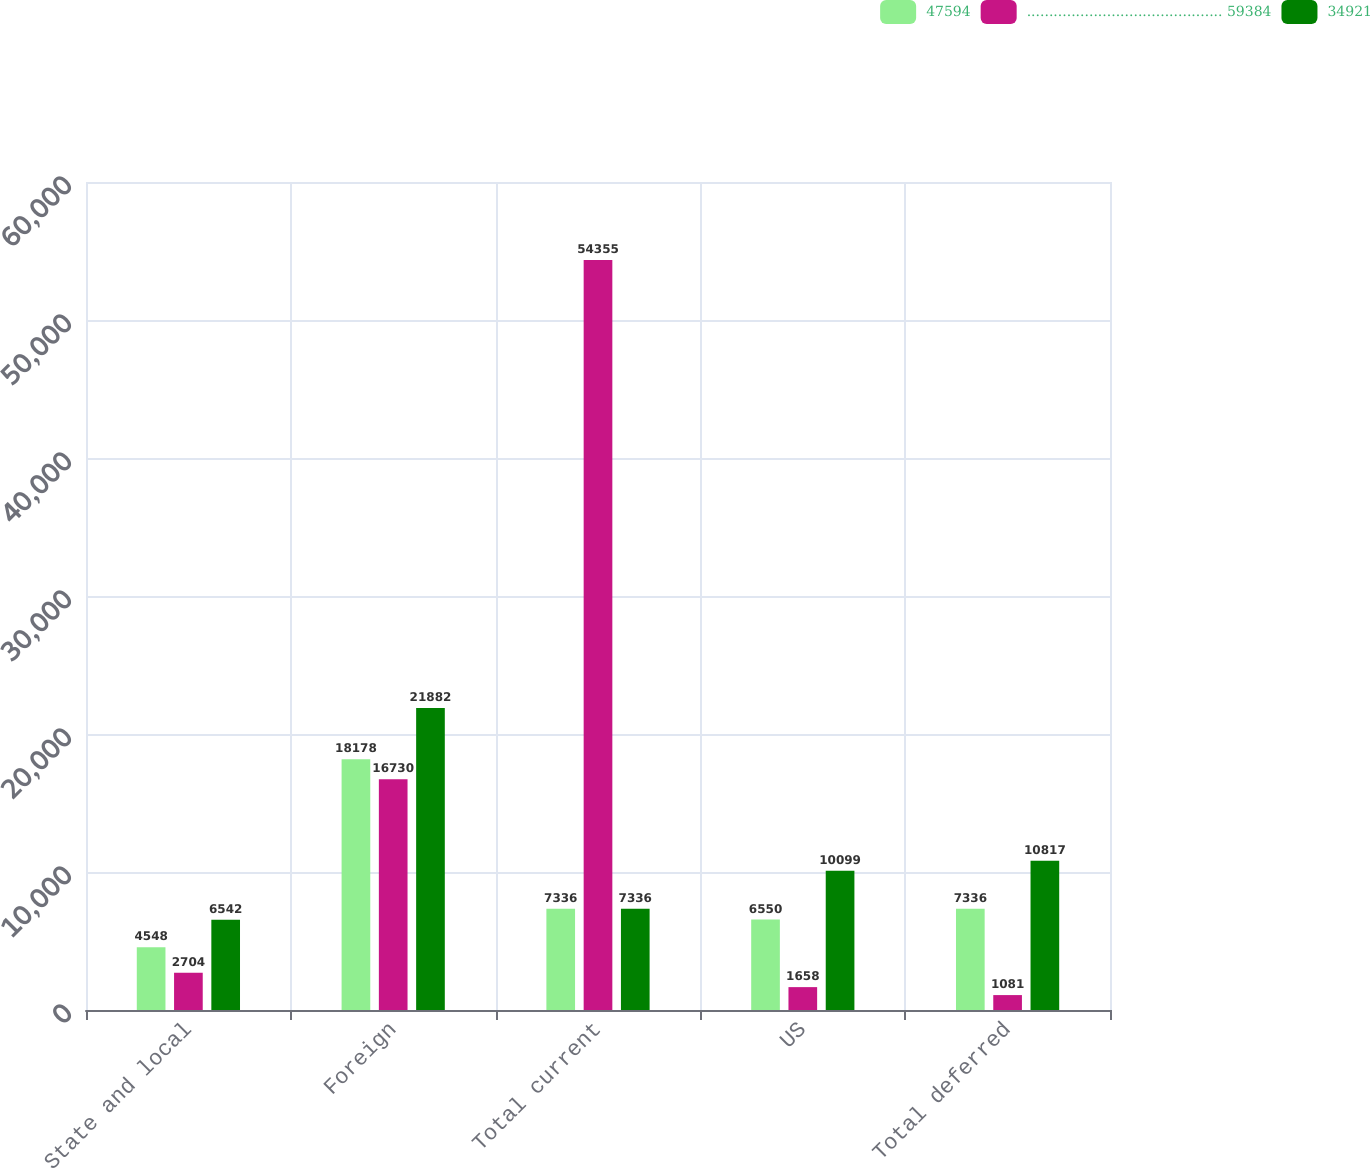Convert chart. <chart><loc_0><loc_0><loc_500><loc_500><stacked_bar_chart><ecel><fcel>State and local<fcel>Foreign<fcel>Total current<fcel>US<fcel>Total deferred<nl><fcel>47594<fcel>4548<fcel>18178<fcel>7336<fcel>6550<fcel>7336<nl><fcel>............................................ 59384<fcel>2704<fcel>16730<fcel>54355<fcel>1658<fcel>1081<nl><fcel>34921<fcel>6542<fcel>21882<fcel>7336<fcel>10099<fcel>10817<nl></chart> 